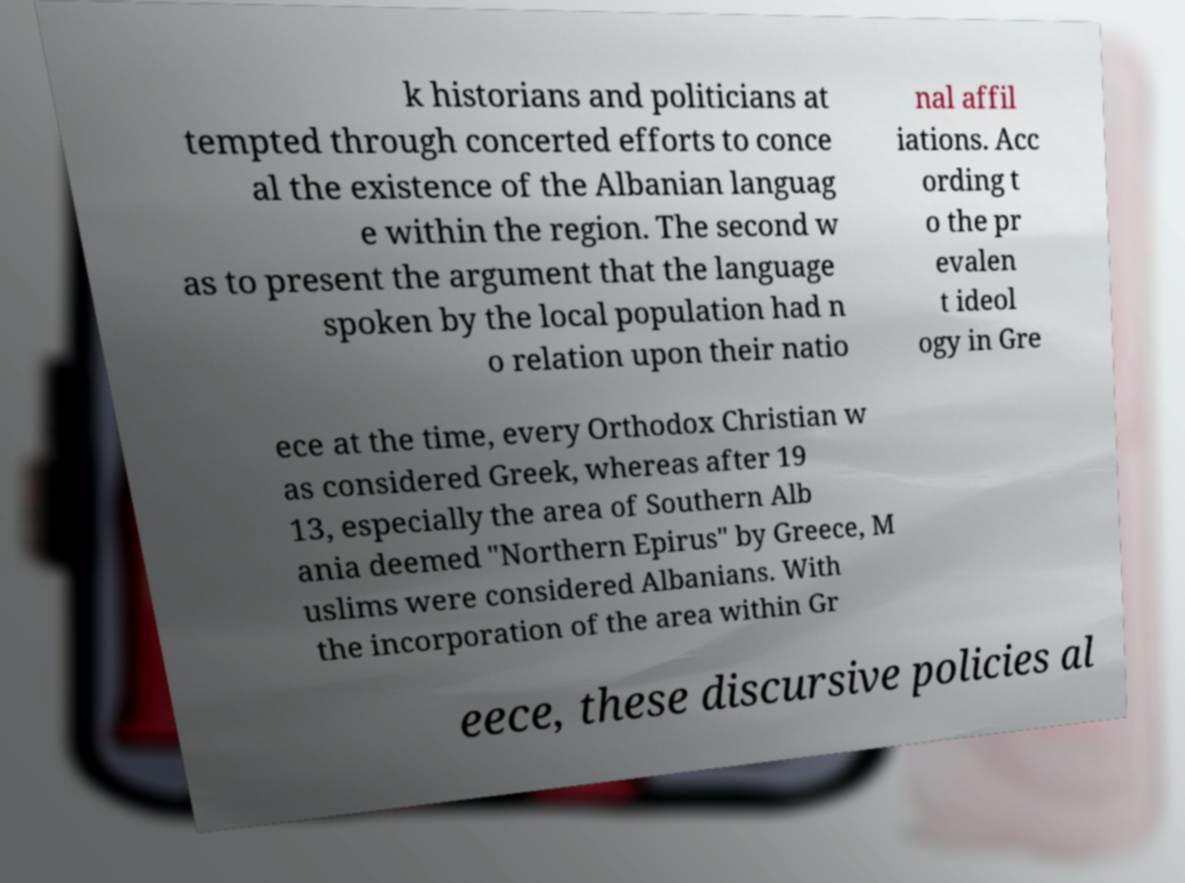Can you read and provide the text displayed in the image?This photo seems to have some interesting text. Can you extract and type it out for me? k historians and politicians at tempted through concerted efforts to conce al the existence of the Albanian languag e within the region. The second w as to present the argument that the language spoken by the local population had n o relation upon their natio nal affil iations. Acc ording t o the pr evalen t ideol ogy in Gre ece at the time, every Orthodox Christian w as considered Greek, whereas after 19 13, especially the area of Southern Alb ania deemed "Northern Epirus" by Greece, M uslims were considered Albanians. With the incorporation of the area within Gr eece, these discursive policies al 